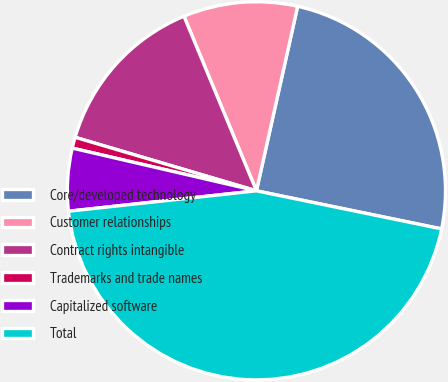<chart> <loc_0><loc_0><loc_500><loc_500><pie_chart><fcel>Core/developed technology<fcel>Customer relationships<fcel>Contract rights intangible<fcel>Trademarks and trade names<fcel>Capitalized software<fcel>Total<nl><fcel>24.73%<fcel>9.76%<fcel>14.17%<fcel>0.94%<fcel>5.35%<fcel>45.05%<nl></chart> 